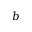<formula> <loc_0><loc_0><loc_500><loc_500>b</formula> 